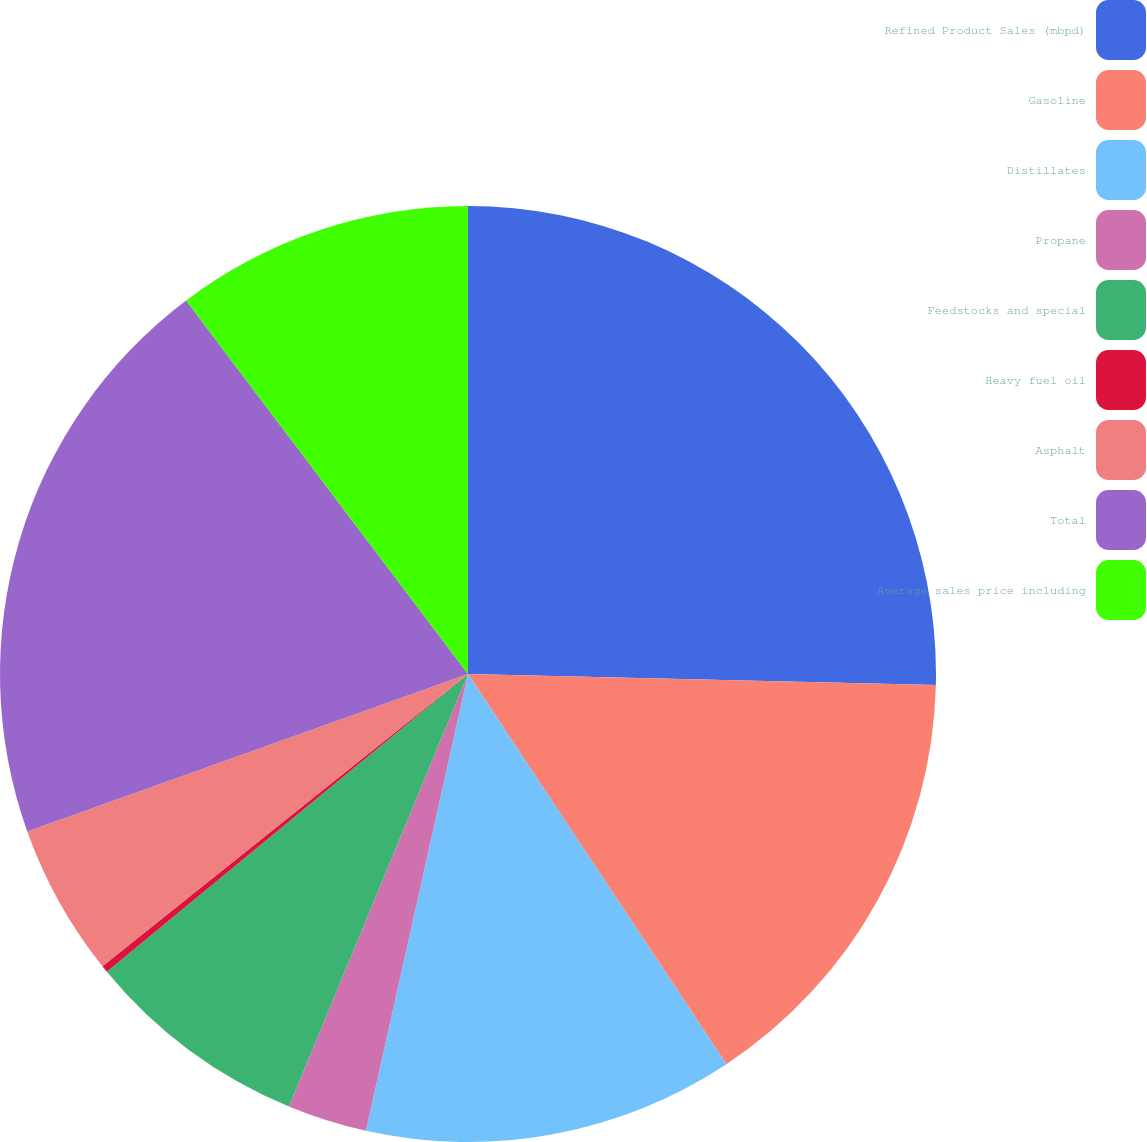Convert chart. <chart><loc_0><loc_0><loc_500><loc_500><pie_chart><fcel>Refined Product Sales (mbpd)<fcel>Gasoline<fcel>Distillates<fcel>Propane<fcel>Feedstocks and special<fcel>Heavy fuel oil<fcel>Asphalt<fcel>Total<fcel>Average sales price including<nl><fcel>25.37%<fcel>15.32%<fcel>12.81%<fcel>2.75%<fcel>7.78%<fcel>0.24%<fcel>5.27%<fcel>20.17%<fcel>10.29%<nl></chart> 